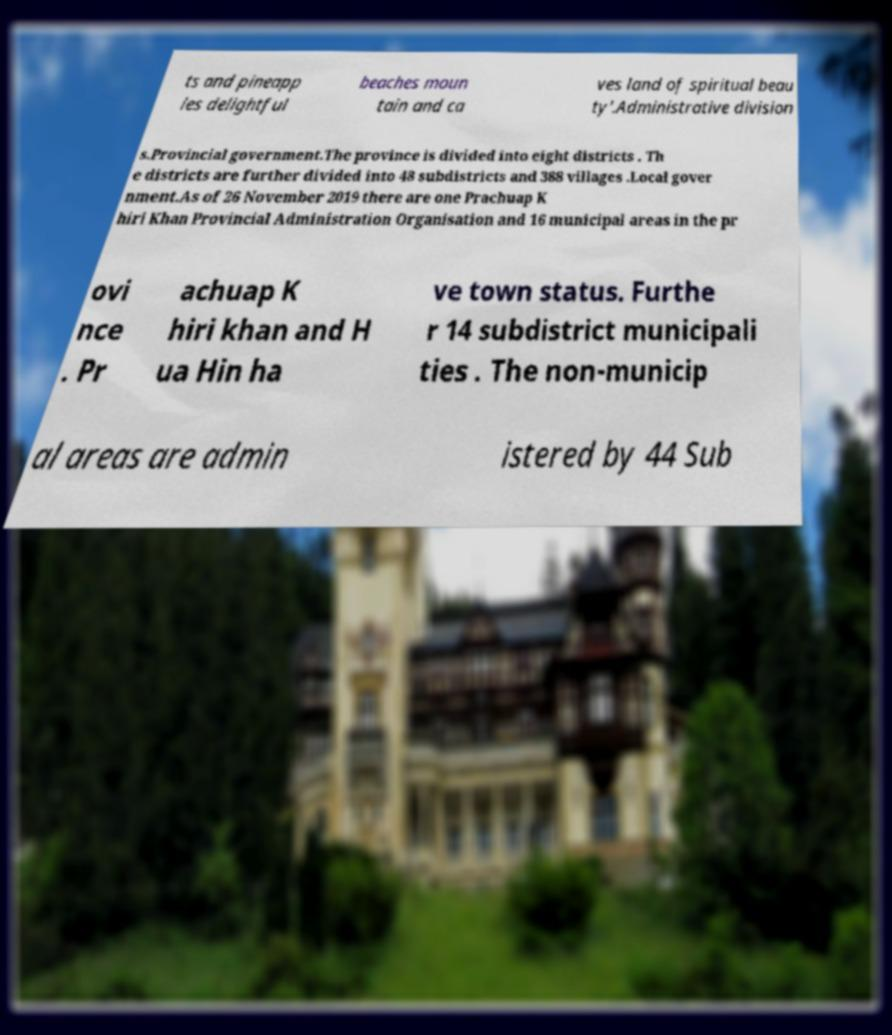Can you read and provide the text displayed in the image?This photo seems to have some interesting text. Can you extract and type it out for me? ts and pineapp les delightful beaches moun tain and ca ves land of spiritual beau ty'.Administrative division s.Provincial government.The province is divided into eight districts . Th e districts are further divided into 48 subdistricts and 388 villages .Local gover nment.As of 26 November 2019 there are one Prachuap K hiri Khan Provincial Administration Organisation and 16 municipal areas in the pr ovi nce . Pr achuap K hiri khan and H ua Hin ha ve town status. Furthe r 14 subdistrict municipali ties . The non-municip al areas are admin istered by 44 Sub 